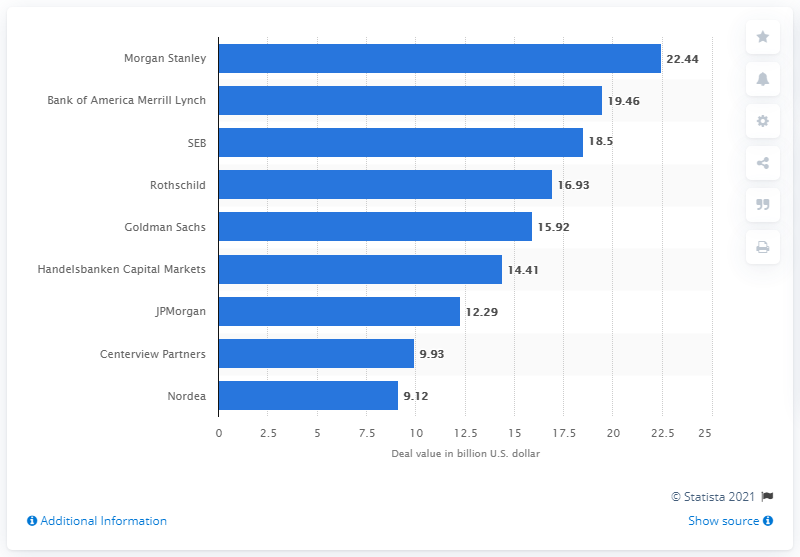Outline some significant characteristics in this image. According to sources, Morgan Stanley was the top advisor for M&A deals in the Nordic region in 2016. In 2016, the deal value of Morgan Stanley was 22.44. 